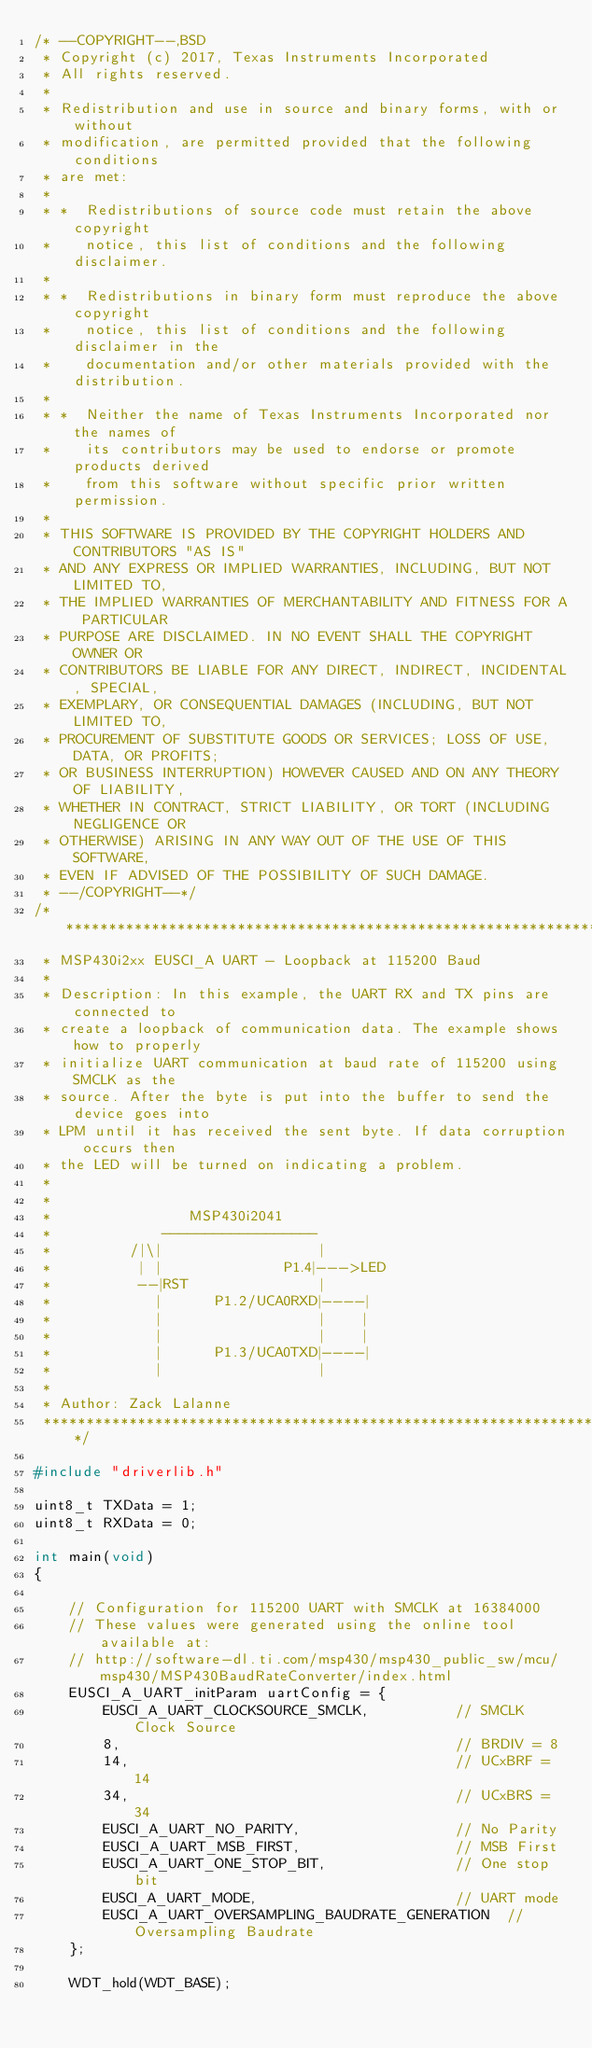<code> <loc_0><loc_0><loc_500><loc_500><_C_>/* --COPYRIGHT--,BSD
 * Copyright (c) 2017, Texas Instruments Incorporated
 * All rights reserved.
 *
 * Redistribution and use in source and binary forms, with or without
 * modification, are permitted provided that the following conditions
 * are met:
 *
 * *  Redistributions of source code must retain the above copyright
 *    notice, this list of conditions and the following disclaimer.
 *
 * *  Redistributions in binary form must reproduce the above copyright
 *    notice, this list of conditions and the following disclaimer in the
 *    documentation and/or other materials provided with the distribution.
 *
 * *  Neither the name of Texas Instruments Incorporated nor the names of
 *    its contributors may be used to endorse or promote products derived
 *    from this software without specific prior written permission.
 *
 * THIS SOFTWARE IS PROVIDED BY THE COPYRIGHT HOLDERS AND CONTRIBUTORS "AS IS"
 * AND ANY EXPRESS OR IMPLIED WARRANTIES, INCLUDING, BUT NOT LIMITED TO,
 * THE IMPLIED WARRANTIES OF MERCHANTABILITY AND FITNESS FOR A PARTICULAR
 * PURPOSE ARE DISCLAIMED. IN NO EVENT SHALL THE COPYRIGHT OWNER OR
 * CONTRIBUTORS BE LIABLE FOR ANY DIRECT, INDIRECT, INCIDENTAL, SPECIAL,
 * EXEMPLARY, OR CONSEQUENTIAL DAMAGES (INCLUDING, BUT NOT LIMITED TO,
 * PROCUREMENT OF SUBSTITUTE GOODS OR SERVICES; LOSS OF USE, DATA, OR PROFITS;
 * OR BUSINESS INTERRUPTION) HOWEVER CAUSED AND ON ANY THEORY OF LIABILITY,
 * WHETHER IN CONTRACT, STRICT LIABILITY, OR TORT (INCLUDING NEGLIGENCE OR
 * OTHERWISE) ARISING IN ANY WAY OUT OF THE USE OF THIS SOFTWARE,
 * EVEN IF ADVISED OF THE POSSIBILITY OF SUCH DAMAGE.
 * --/COPYRIGHT--*/
/*******************************************************************************
 * MSP430i2xx EUSCI_A UART - Loopback at 115200 Baud
 *
 * Description: In this example, the UART RX and TX pins are connected to
 * create a loopback of communication data. The example shows how to properly
 * initialize UART communication at baud rate of 115200 using SMCLK as the
 * source. After the byte is put into the buffer to send the device goes into
 * LPM until it has received the sent byte. If data corruption occurs then
 * the LED will be turned on indicating a problem.
 *
 *
 *                MSP430i2041
 *             ------------------
 *         /|\|                  |
 *          | |              P1.4|--->LED
 *          --|RST               |
 *            |      P1.2/UCA0RXD|----|
 *            |                  |    |
 *            |                  |    |
 *            |      P1.3/UCA0TXD|----|
 *            |                  |
 *
 * Author: Zack Lalanne
 ******************************************************************************/

#include "driverlib.h"

uint8_t TXData = 1;
uint8_t RXData = 0;

int main(void)
{

    // Configuration for 115200 UART with SMCLK at 16384000
    // These values were generated using the online tool available at:
    // http://software-dl.ti.com/msp430/msp430_public_sw/mcu/msp430/MSP430BaudRateConverter/index.html
    EUSCI_A_UART_initParam uartConfig = {
        EUSCI_A_UART_CLOCKSOURCE_SMCLK,          // SMCLK Clock Source
        8,                                       // BRDIV = 8
        14,                                      // UCxBRF = 14
        34,                                      // UCxBRS = 34
        EUSCI_A_UART_NO_PARITY,                  // No Parity
        EUSCI_A_UART_MSB_FIRST,                  // MSB First
        EUSCI_A_UART_ONE_STOP_BIT,               // One stop bit
        EUSCI_A_UART_MODE,                       // UART mode
        EUSCI_A_UART_OVERSAMPLING_BAUDRATE_GENERATION  // Oversampling Baudrate
    };

    WDT_hold(WDT_BASE);
</code> 